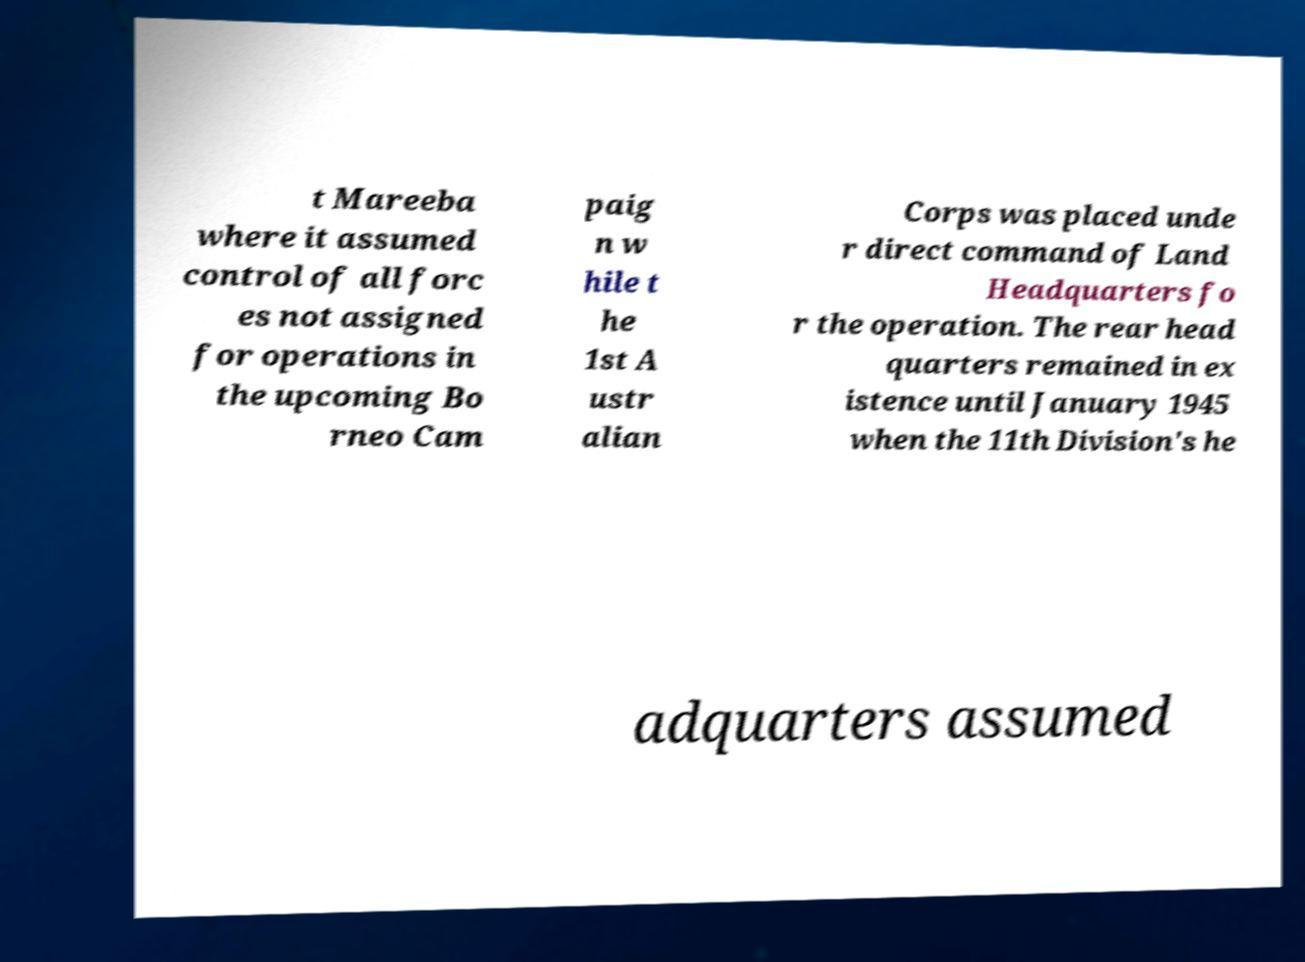Please identify and transcribe the text found in this image. t Mareeba where it assumed control of all forc es not assigned for operations in the upcoming Bo rneo Cam paig n w hile t he 1st A ustr alian Corps was placed unde r direct command of Land Headquarters fo r the operation. The rear head quarters remained in ex istence until January 1945 when the 11th Division's he adquarters assumed 